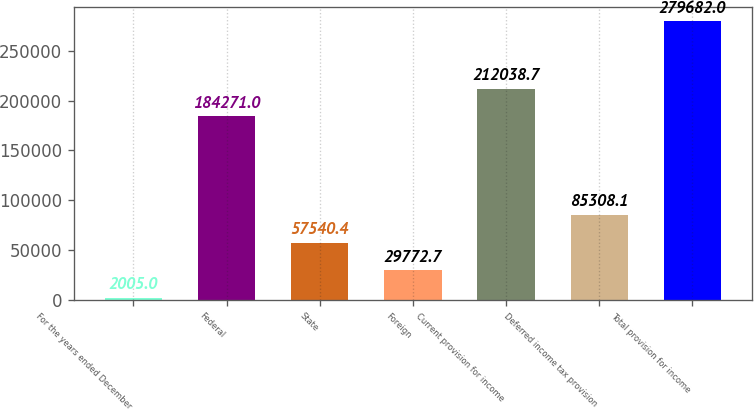Convert chart. <chart><loc_0><loc_0><loc_500><loc_500><bar_chart><fcel>For the years ended December<fcel>Federal<fcel>State<fcel>Foreign<fcel>Current provision for income<fcel>Deferred income tax provision<fcel>Total provision for income<nl><fcel>2005<fcel>184271<fcel>57540.4<fcel>29772.7<fcel>212039<fcel>85308.1<fcel>279682<nl></chart> 